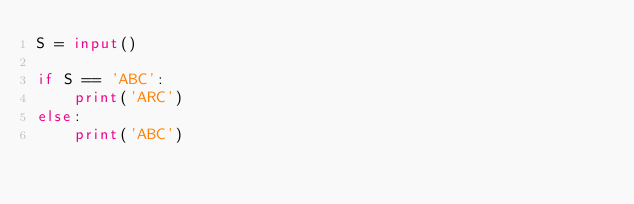Convert code to text. <code><loc_0><loc_0><loc_500><loc_500><_Python_>S = input()

if S == 'ABC':
    print('ARC')
else:
    print('ABC')</code> 